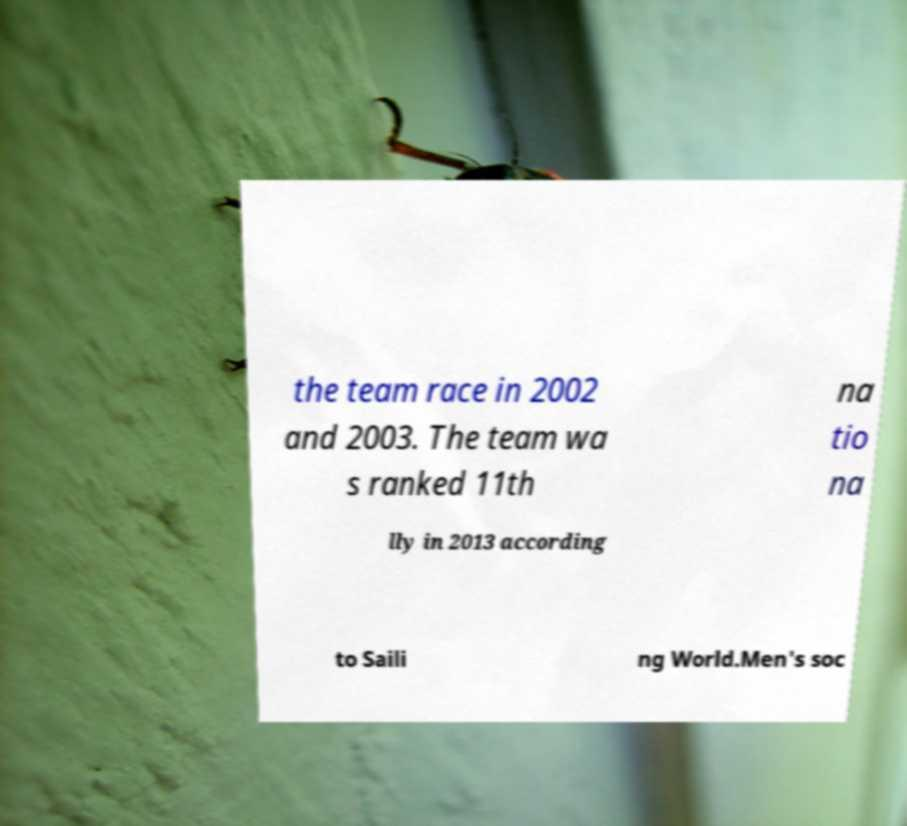Could you assist in decoding the text presented in this image and type it out clearly? the team race in 2002 and 2003. The team wa s ranked 11th na tio na lly in 2013 according to Saili ng World.Men's soc 